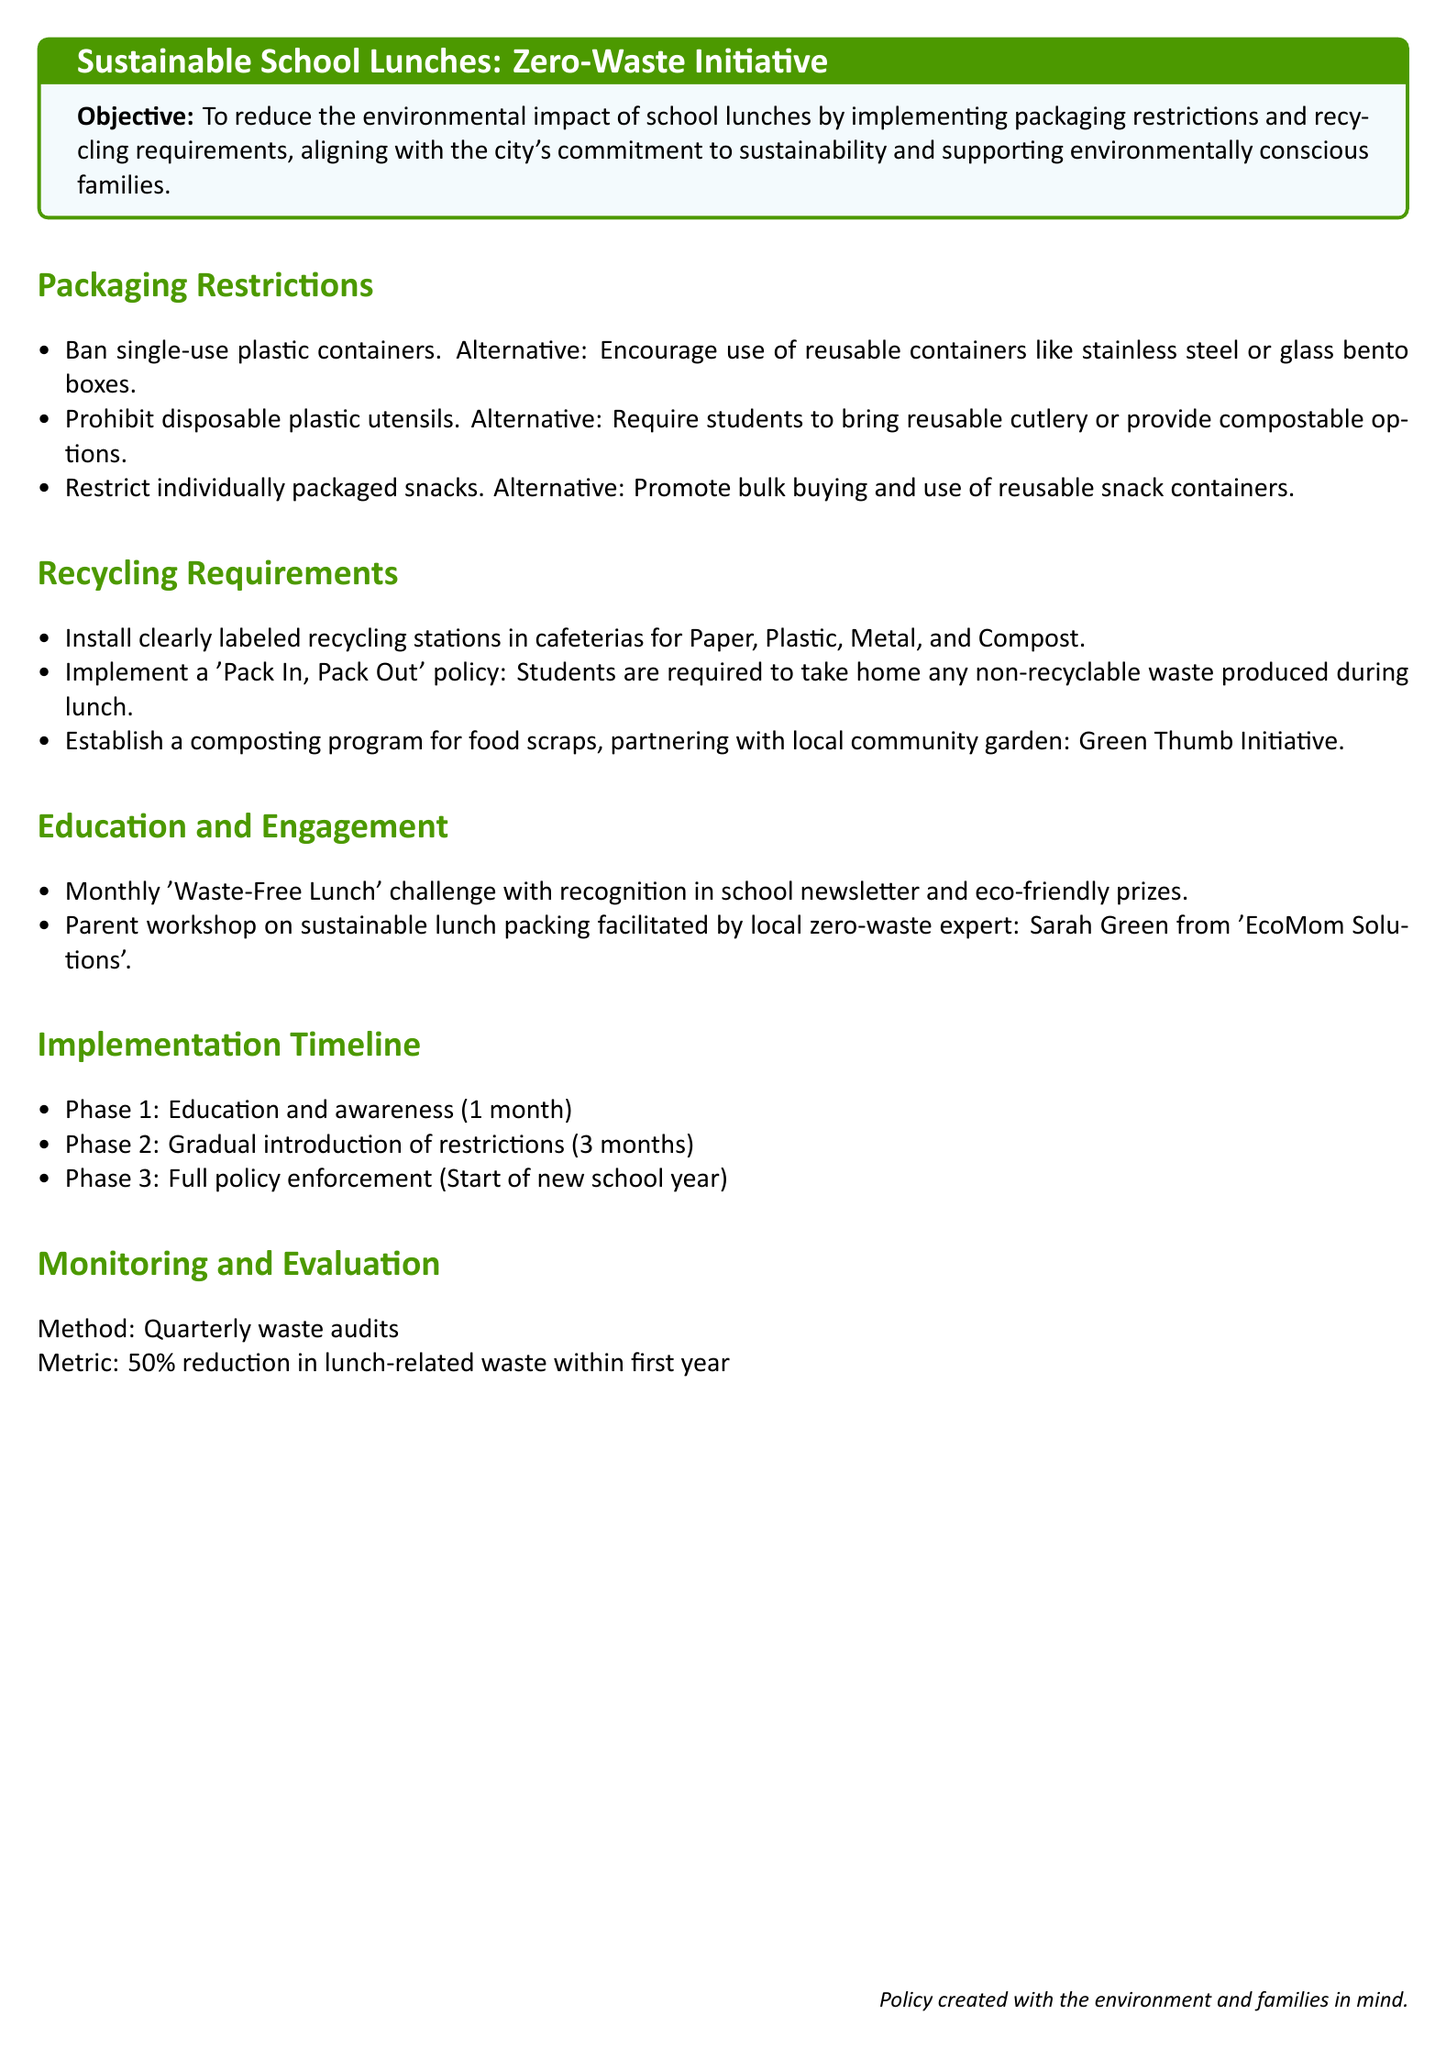What is the objective of the Zero-Waste Initiative? The objective is to reduce the environmental impact of school lunches by implementing packaging restrictions and recycling requirements.
Answer: To reduce the environmental impact of school lunches What is prohibited under the packaging restrictions? The document states that single-use plastic containers are banned.
Answer: Single-use plastic containers What is one alternative for disposable plastic utensils? The document suggests requiring students to bring reusable cutlery.
Answer: Reusable cutlery What does the 'Pack In, Pack Out' policy entail? It requires students to take home any non-recyclable waste produced during lunch.
Answer: Take home non-recyclable waste What is the metric for evaluating the initiative's success? The document mentions a 50% reduction in lunch-related waste within the first year.
Answer: 50% reduction Who facilitates the parent workshop on sustainable lunch packing? The document identifies Sarah Green from 'EcoMom Solutions' as the facilitator.
Answer: Sarah Green How long is the education and awareness phase? The timeline indicates that this phase lasts for one month.
Answer: 1 month What is the name of the composting program established? The composting program is called the Green Thumb Initiative.
Answer: Green Thumb Initiative What is the duration of the gradual introduction of restrictions? According to the timeline, this phase lasts for three months.
Answer: 3 months 